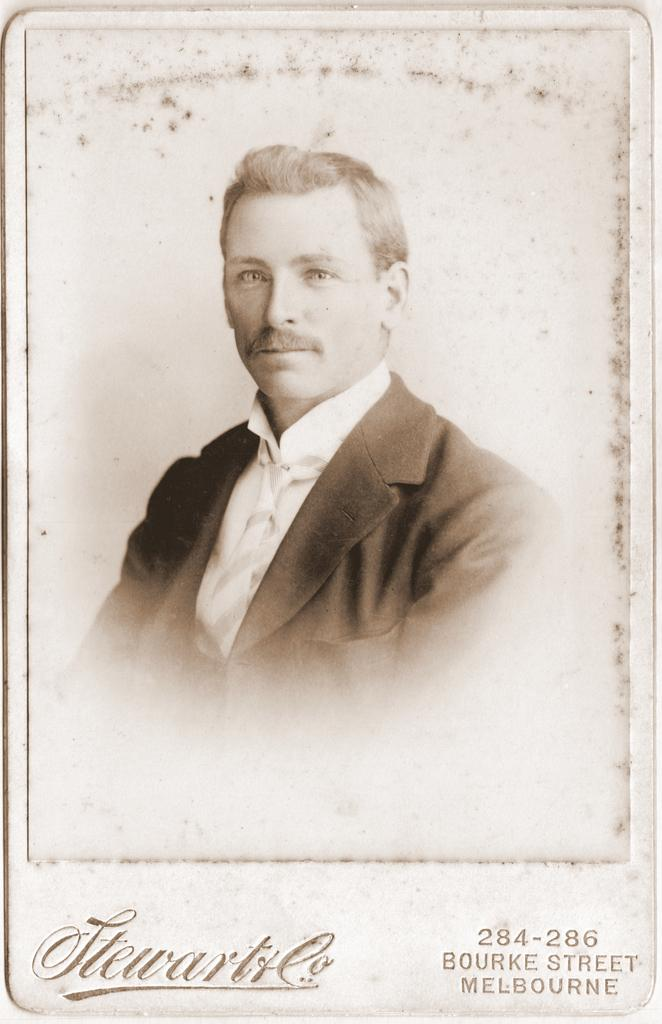What type of artwork is depicted in the image? The image is a painting. Who or what can be seen in the painting? There is a man in the painting. Is there any text present in the painting? Yes, there is text at the bottom of the painting. Can you see any ghosts in the painting? No, there are no ghosts present in the painting. What type of shock can be seen on the man's face in the painting? There is no shock visible on the man's face in the painting. 